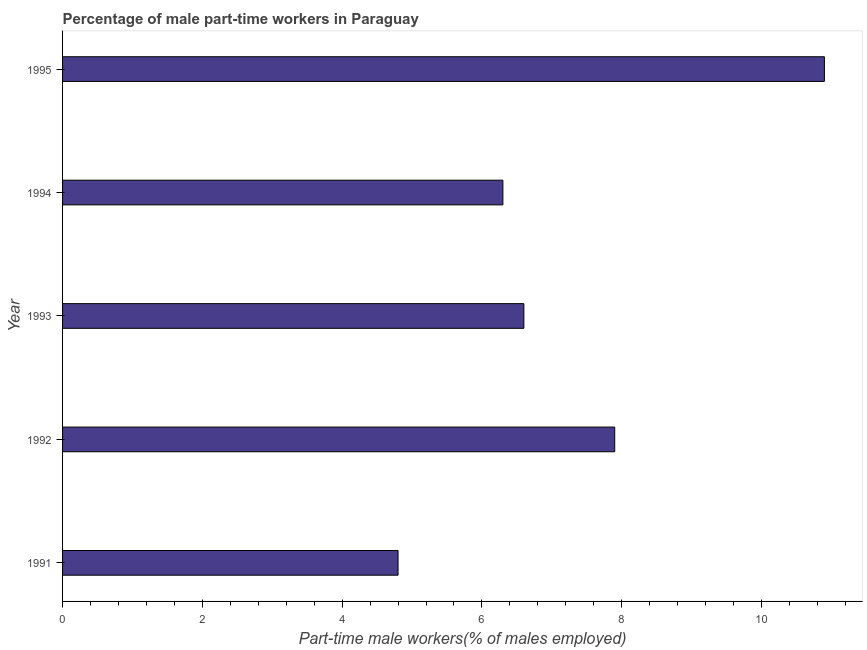Does the graph contain any zero values?
Your answer should be very brief. No. What is the title of the graph?
Offer a terse response. Percentage of male part-time workers in Paraguay. What is the label or title of the X-axis?
Keep it short and to the point. Part-time male workers(% of males employed). What is the label or title of the Y-axis?
Your response must be concise. Year. What is the percentage of part-time male workers in 1993?
Keep it short and to the point. 6.6. Across all years, what is the maximum percentage of part-time male workers?
Provide a succinct answer. 10.9. Across all years, what is the minimum percentage of part-time male workers?
Make the answer very short. 4.8. In which year was the percentage of part-time male workers maximum?
Provide a short and direct response. 1995. What is the sum of the percentage of part-time male workers?
Give a very brief answer. 36.5. What is the median percentage of part-time male workers?
Ensure brevity in your answer.  6.6. In how many years, is the percentage of part-time male workers greater than 9.6 %?
Your answer should be compact. 1. Do a majority of the years between 1992 and 1994 (inclusive) have percentage of part-time male workers greater than 8 %?
Provide a succinct answer. No. What is the ratio of the percentage of part-time male workers in 1993 to that in 1995?
Your answer should be very brief. 0.61. Is the percentage of part-time male workers in 1992 less than that in 1994?
Offer a very short reply. No. What is the difference between the highest and the second highest percentage of part-time male workers?
Provide a short and direct response. 3. What is the difference between the highest and the lowest percentage of part-time male workers?
Your response must be concise. 6.1. In how many years, is the percentage of part-time male workers greater than the average percentage of part-time male workers taken over all years?
Ensure brevity in your answer.  2. How many years are there in the graph?
Give a very brief answer. 5. What is the Part-time male workers(% of males employed) in 1991?
Your response must be concise. 4.8. What is the Part-time male workers(% of males employed) of 1992?
Make the answer very short. 7.9. What is the Part-time male workers(% of males employed) in 1993?
Your answer should be compact. 6.6. What is the Part-time male workers(% of males employed) in 1994?
Offer a very short reply. 6.3. What is the Part-time male workers(% of males employed) of 1995?
Your answer should be compact. 10.9. What is the difference between the Part-time male workers(% of males employed) in 1991 and 1995?
Offer a very short reply. -6.1. What is the difference between the Part-time male workers(% of males employed) in 1992 and 1993?
Offer a terse response. 1.3. What is the difference between the Part-time male workers(% of males employed) in 1993 and 1994?
Make the answer very short. 0.3. What is the difference between the Part-time male workers(% of males employed) in 1993 and 1995?
Your answer should be very brief. -4.3. What is the ratio of the Part-time male workers(% of males employed) in 1991 to that in 1992?
Your response must be concise. 0.61. What is the ratio of the Part-time male workers(% of males employed) in 1991 to that in 1993?
Your response must be concise. 0.73. What is the ratio of the Part-time male workers(% of males employed) in 1991 to that in 1994?
Your answer should be compact. 0.76. What is the ratio of the Part-time male workers(% of males employed) in 1991 to that in 1995?
Keep it short and to the point. 0.44. What is the ratio of the Part-time male workers(% of males employed) in 1992 to that in 1993?
Your answer should be very brief. 1.2. What is the ratio of the Part-time male workers(% of males employed) in 1992 to that in 1994?
Offer a terse response. 1.25. What is the ratio of the Part-time male workers(% of males employed) in 1992 to that in 1995?
Offer a terse response. 0.72. What is the ratio of the Part-time male workers(% of males employed) in 1993 to that in 1994?
Offer a terse response. 1.05. What is the ratio of the Part-time male workers(% of males employed) in 1993 to that in 1995?
Offer a terse response. 0.61. What is the ratio of the Part-time male workers(% of males employed) in 1994 to that in 1995?
Offer a very short reply. 0.58. 